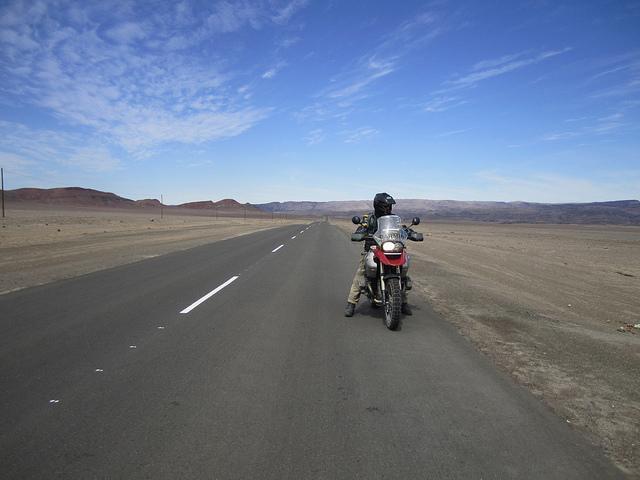How many bikes are on the road?
Give a very brief answer. 1. 